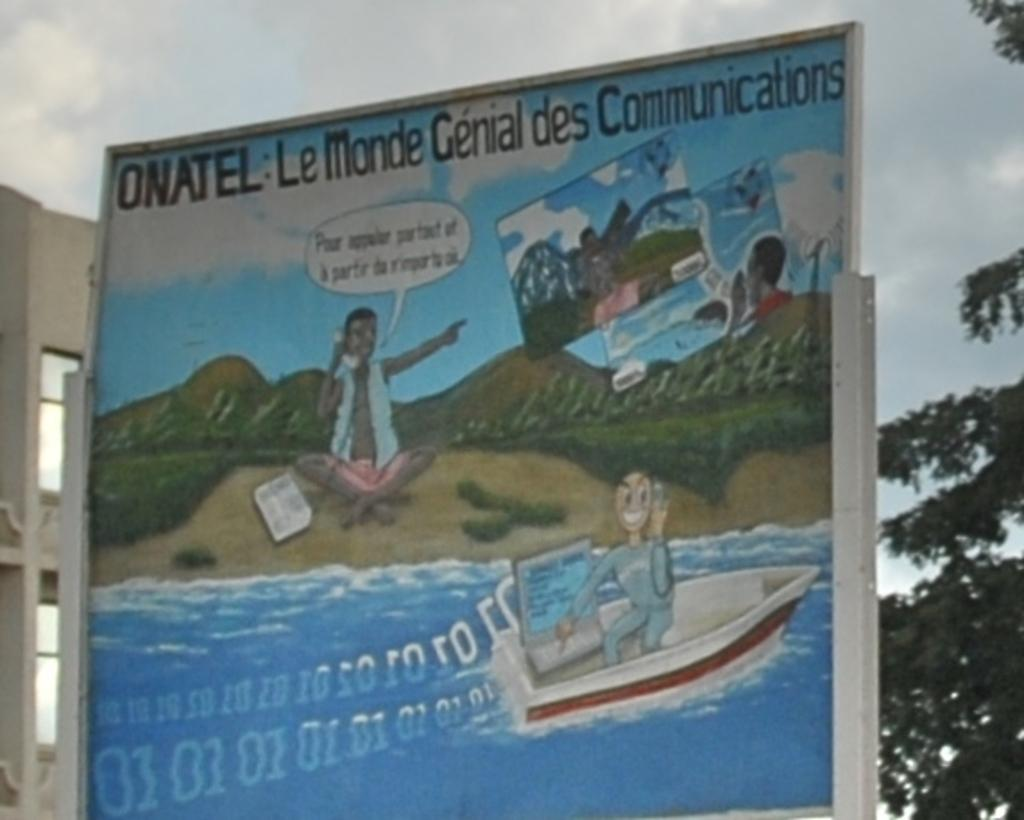Provide a one-sentence caption for the provided image. A sign advertising ONATEL in French has scene with a boat on a river. 